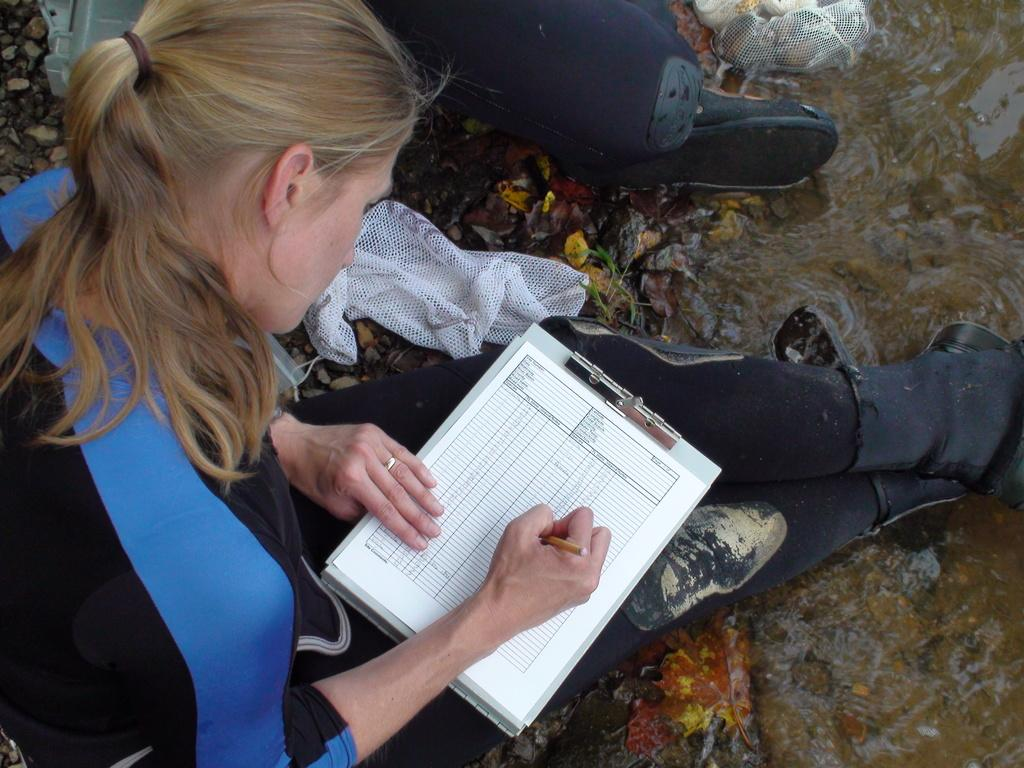What is the woman in the image doing? The woman is sitting in the center of the image and writing on a paper. Can you describe the background of the image? There is a blanket and a cloth in the background of the image, along with other unspecified objects. What type of mist can be seen in the image? There is no mist present in the image. What is the woman using to lead the horses in the image? There are no horses or any indication of leading in the image; the woman is simply writing on a paper. 